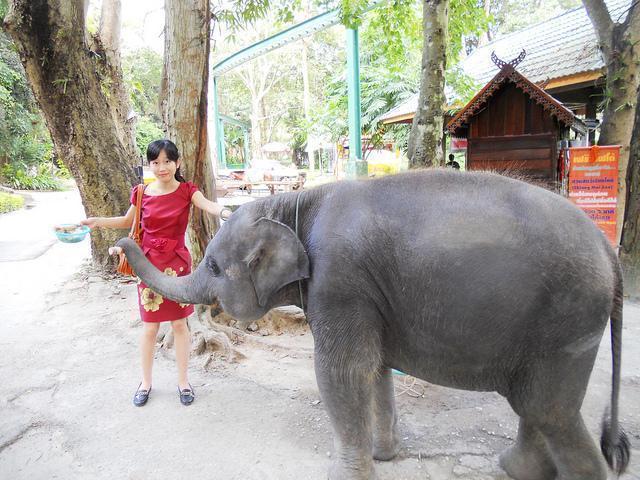What does the elephant here seek?
Choose the right answer from the provided options to respond to the question.
Options: Love, nothing, food, mate. Food. 